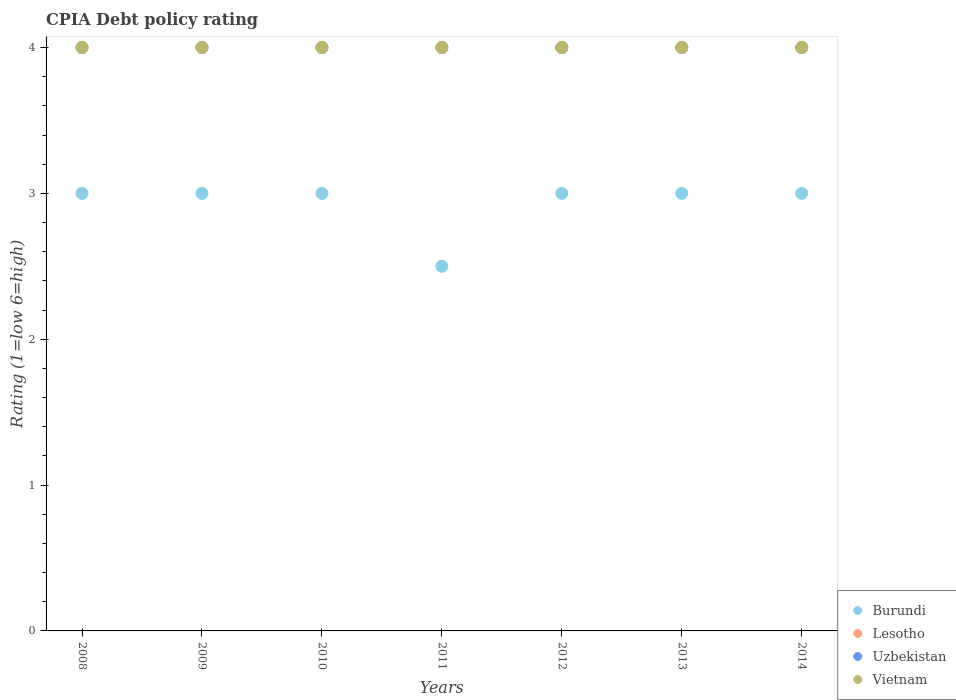What is the CPIA rating in Lesotho in 2011?
Ensure brevity in your answer.  4. Across all years, what is the maximum CPIA rating in Lesotho?
Ensure brevity in your answer.  4. Across all years, what is the minimum CPIA rating in Vietnam?
Ensure brevity in your answer.  4. In the year 2011, what is the difference between the CPIA rating in Lesotho and CPIA rating in Vietnam?
Ensure brevity in your answer.  0. What is the ratio of the CPIA rating in Burundi in 2009 to that in 2012?
Your answer should be very brief. 1. Is the difference between the CPIA rating in Lesotho in 2009 and 2012 greater than the difference between the CPIA rating in Vietnam in 2009 and 2012?
Ensure brevity in your answer.  No. What is the difference between the highest and the second highest CPIA rating in Uzbekistan?
Your answer should be compact. 0. In how many years, is the CPIA rating in Vietnam greater than the average CPIA rating in Vietnam taken over all years?
Ensure brevity in your answer.  0. Is the sum of the CPIA rating in Uzbekistan in 2009 and 2014 greater than the maximum CPIA rating in Vietnam across all years?
Offer a terse response. Yes. Does the CPIA rating in Vietnam monotonically increase over the years?
Give a very brief answer. No. Is the CPIA rating in Burundi strictly greater than the CPIA rating in Uzbekistan over the years?
Make the answer very short. No. Is the CPIA rating in Burundi strictly less than the CPIA rating in Vietnam over the years?
Offer a terse response. Yes. How many dotlines are there?
Keep it short and to the point. 4. Are the values on the major ticks of Y-axis written in scientific E-notation?
Offer a very short reply. No. Does the graph contain any zero values?
Your answer should be very brief. No. Does the graph contain grids?
Give a very brief answer. No. Where does the legend appear in the graph?
Your answer should be compact. Bottom right. How are the legend labels stacked?
Your answer should be very brief. Vertical. What is the title of the graph?
Your answer should be compact. CPIA Debt policy rating. Does "Bahrain" appear as one of the legend labels in the graph?
Keep it short and to the point. No. What is the Rating (1=low 6=high) of Uzbekistan in 2008?
Provide a short and direct response. 4. What is the Rating (1=low 6=high) in Uzbekistan in 2009?
Your response must be concise. 4. What is the Rating (1=low 6=high) of Vietnam in 2009?
Make the answer very short. 4. What is the Rating (1=low 6=high) in Uzbekistan in 2010?
Provide a short and direct response. 4. What is the Rating (1=low 6=high) in Burundi in 2011?
Your response must be concise. 2.5. What is the Rating (1=low 6=high) of Uzbekistan in 2011?
Offer a terse response. 4. What is the Rating (1=low 6=high) of Burundi in 2012?
Make the answer very short. 3. What is the Rating (1=low 6=high) of Lesotho in 2012?
Your answer should be very brief. 4. What is the Rating (1=low 6=high) in Uzbekistan in 2012?
Your response must be concise. 4. What is the Rating (1=low 6=high) in Burundi in 2013?
Give a very brief answer. 3. What is the Rating (1=low 6=high) of Vietnam in 2013?
Offer a terse response. 4. What is the Rating (1=low 6=high) in Burundi in 2014?
Your response must be concise. 3. What is the Rating (1=low 6=high) of Uzbekistan in 2014?
Provide a succinct answer. 4. Across all years, what is the maximum Rating (1=low 6=high) in Uzbekistan?
Offer a terse response. 4. Across all years, what is the minimum Rating (1=low 6=high) of Lesotho?
Provide a succinct answer. 4. What is the difference between the Rating (1=low 6=high) in Burundi in 2008 and that in 2009?
Keep it short and to the point. 0. What is the difference between the Rating (1=low 6=high) of Uzbekistan in 2008 and that in 2009?
Your answer should be very brief. 0. What is the difference between the Rating (1=low 6=high) in Vietnam in 2008 and that in 2009?
Provide a succinct answer. 0. What is the difference between the Rating (1=low 6=high) in Burundi in 2008 and that in 2010?
Provide a short and direct response. 0. What is the difference between the Rating (1=low 6=high) of Lesotho in 2008 and that in 2010?
Your response must be concise. 0. What is the difference between the Rating (1=low 6=high) of Vietnam in 2008 and that in 2010?
Your answer should be compact. 0. What is the difference between the Rating (1=low 6=high) of Burundi in 2008 and that in 2011?
Make the answer very short. 0.5. What is the difference between the Rating (1=low 6=high) of Lesotho in 2008 and that in 2011?
Provide a succinct answer. 0. What is the difference between the Rating (1=low 6=high) in Burundi in 2008 and that in 2012?
Offer a terse response. 0. What is the difference between the Rating (1=low 6=high) of Uzbekistan in 2008 and that in 2014?
Provide a succinct answer. 0. What is the difference between the Rating (1=low 6=high) of Vietnam in 2008 and that in 2014?
Provide a succinct answer. 0. What is the difference between the Rating (1=low 6=high) in Burundi in 2009 and that in 2010?
Your response must be concise. 0. What is the difference between the Rating (1=low 6=high) in Uzbekistan in 2009 and that in 2010?
Keep it short and to the point. 0. What is the difference between the Rating (1=low 6=high) in Vietnam in 2009 and that in 2010?
Your answer should be compact. 0. What is the difference between the Rating (1=low 6=high) of Uzbekistan in 2009 and that in 2011?
Make the answer very short. 0. What is the difference between the Rating (1=low 6=high) of Vietnam in 2009 and that in 2011?
Make the answer very short. 0. What is the difference between the Rating (1=low 6=high) of Uzbekistan in 2009 and that in 2012?
Offer a terse response. 0. What is the difference between the Rating (1=low 6=high) of Vietnam in 2009 and that in 2012?
Your response must be concise. 0. What is the difference between the Rating (1=low 6=high) of Burundi in 2009 and that in 2013?
Provide a succinct answer. 0. What is the difference between the Rating (1=low 6=high) of Uzbekistan in 2009 and that in 2013?
Provide a succinct answer. 0. What is the difference between the Rating (1=low 6=high) in Burundi in 2009 and that in 2014?
Provide a succinct answer. 0. What is the difference between the Rating (1=low 6=high) in Lesotho in 2009 and that in 2014?
Ensure brevity in your answer.  0. What is the difference between the Rating (1=low 6=high) of Uzbekistan in 2009 and that in 2014?
Your answer should be very brief. 0. What is the difference between the Rating (1=low 6=high) of Vietnam in 2009 and that in 2014?
Keep it short and to the point. 0. What is the difference between the Rating (1=low 6=high) in Burundi in 2010 and that in 2012?
Give a very brief answer. 0. What is the difference between the Rating (1=low 6=high) of Lesotho in 2010 and that in 2012?
Make the answer very short. 0. What is the difference between the Rating (1=low 6=high) in Uzbekistan in 2010 and that in 2012?
Provide a succinct answer. 0. What is the difference between the Rating (1=low 6=high) in Vietnam in 2010 and that in 2012?
Offer a very short reply. 0. What is the difference between the Rating (1=low 6=high) in Lesotho in 2010 and that in 2014?
Your answer should be compact. 0. What is the difference between the Rating (1=low 6=high) in Burundi in 2011 and that in 2012?
Ensure brevity in your answer.  -0.5. What is the difference between the Rating (1=low 6=high) of Lesotho in 2011 and that in 2012?
Give a very brief answer. 0. What is the difference between the Rating (1=low 6=high) of Uzbekistan in 2011 and that in 2012?
Provide a succinct answer. 0. What is the difference between the Rating (1=low 6=high) of Vietnam in 2011 and that in 2012?
Provide a short and direct response. 0. What is the difference between the Rating (1=low 6=high) of Lesotho in 2011 and that in 2013?
Provide a short and direct response. 0. What is the difference between the Rating (1=low 6=high) of Vietnam in 2011 and that in 2013?
Make the answer very short. 0. What is the difference between the Rating (1=low 6=high) in Uzbekistan in 2011 and that in 2014?
Offer a very short reply. 0. What is the difference between the Rating (1=low 6=high) in Burundi in 2012 and that in 2013?
Offer a very short reply. 0. What is the difference between the Rating (1=low 6=high) of Lesotho in 2012 and that in 2013?
Keep it short and to the point. 0. What is the difference between the Rating (1=low 6=high) of Vietnam in 2012 and that in 2013?
Offer a terse response. 0. What is the difference between the Rating (1=low 6=high) in Burundi in 2012 and that in 2014?
Make the answer very short. 0. What is the difference between the Rating (1=low 6=high) in Lesotho in 2012 and that in 2014?
Your response must be concise. 0. What is the difference between the Rating (1=low 6=high) of Vietnam in 2012 and that in 2014?
Offer a very short reply. 0. What is the difference between the Rating (1=low 6=high) in Uzbekistan in 2013 and that in 2014?
Give a very brief answer. 0. What is the difference between the Rating (1=low 6=high) in Burundi in 2008 and the Rating (1=low 6=high) in Uzbekistan in 2009?
Your response must be concise. -1. What is the difference between the Rating (1=low 6=high) in Uzbekistan in 2008 and the Rating (1=low 6=high) in Vietnam in 2009?
Make the answer very short. 0. What is the difference between the Rating (1=low 6=high) of Burundi in 2008 and the Rating (1=low 6=high) of Uzbekistan in 2010?
Offer a very short reply. -1. What is the difference between the Rating (1=low 6=high) of Lesotho in 2008 and the Rating (1=low 6=high) of Vietnam in 2010?
Give a very brief answer. 0. What is the difference between the Rating (1=low 6=high) in Burundi in 2008 and the Rating (1=low 6=high) in Lesotho in 2011?
Ensure brevity in your answer.  -1. What is the difference between the Rating (1=low 6=high) in Lesotho in 2008 and the Rating (1=low 6=high) in Uzbekistan in 2011?
Your answer should be compact. 0. What is the difference between the Rating (1=low 6=high) of Uzbekistan in 2008 and the Rating (1=low 6=high) of Vietnam in 2011?
Offer a terse response. 0. What is the difference between the Rating (1=low 6=high) in Burundi in 2008 and the Rating (1=low 6=high) in Uzbekistan in 2012?
Make the answer very short. -1. What is the difference between the Rating (1=low 6=high) in Burundi in 2008 and the Rating (1=low 6=high) in Vietnam in 2012?
Your response must be concise. -1. What is the difference between the Rating (1=low 6=high) of Lesotho in 2008 and the Rating (1=low 6=high) of Uzbekistan in 2012?
Provide a short and direct response. 0. What is the difference between the Rating (1=low 6=high) of Uzbekistan in 2008 and the Rating (1=low 6=high) of Vietnam in 2012?
Give a very brief answer. 0. What is the difference between the Rating (1=low 6=high) in Burundi in 2008 and the Rating (1=low 6=high) in Uzbekistan in 2013?
Make the answer very short. -1. What is the difference between the Rating (1=low 6=high) in Lesotho in 2008 and the Rating (1=low 6=high) in Uzbekistan in 2013?
Your response must be concise. 0. What is the difference between the Rating (1=low 6=high) of Lesotho in 2008 and the Rating (1=low 6=high) of Vietnam in 2013?
Offer a very short reply. 0. What is the difference between the Rating (1=low 6=high) of Uzbekistan in 2008 and the Rating (1=low 6=high) of Vietnam in 2013?
Provide a succinct answer. 0. What is the difference between the Rating (1=low 6=high) of Burundi in 2008 and the Rating (1=low 6=high) of Uzbekistan in 2014?
Provide a short and direct response. -1. What is the difference between the Rating (1=low 6=high) of Uzbekistan in 2008 and the Rating (1=low 6=high) of Vietnam in 2014?
Give a very brief answer. 0. What is the difference between the Rating (1=low 6=high) in Burundi in 2009 and the Rating (1=low 6=high) in Lesotho in 2010?
Your answer should be very brief. -1. What is the difference between the Rating (1=low 6=high) of Burundi in 2009 and the Rating (1=low 6=high) of Uzbekistan in 2010?
Provide a succinct answer. -1. What is the difference between the Rating (1=low 6=high) of Lesotho in 2009 and the Rating (1=low 6=high) of Uzbekistan in 2010?
Provide a short and direct response. 0. What is the difference between the Rating (1=low 6=high) in Lesotho in 2009 and the Rating (1=low 6=high) in Vietnam in 2010?
Your answer should be compact. 0. What is the difference between the Rating (1=low 6=high) of Uzbekistan in 2009 and the Rating (1=low 6=high) of Vietnam in 2010?
Keep it short and to the point. 0. What is the difference between the Rating (1=low 6=high) in Burundi in 2009 and the Rating (1=low 6=high) in Lesotho in 2011?
Make the answer very short. -1. What is the difference between the Rating (1=low 6=high) in Burundi in 2009 and the Rating (1=low 6=high) in Uzbekistan in 2011?
Ensure brevity in your answer.  -1. What is the difference between the Rating (1=low 6=high) of Burundi in 2009 and the Rating (1=low 6=high) of Vietnam in 2011?
Keep it short and to the point. -1. What is the difference between the Rating (1=low 6=high) of Uzbekistan in 2009 and the Rating (1=low 6=high) of Vietnam in 2011?
Provide a short and direct response. 0. What is the difference between the Rating (1=low 6=high) in Burundi in 2009 and the Rating (1=low 6=high) in Uzbekistan in 2012?
Keep it short and to the point. -1. What is the difference between the Rating (1=low 6=high) in Uzbekistan in 2009 and the Rating (1=low 6=high) in Vietnam in 2012?
Your answer should be very brief. 0. What is the difference between the Rating (1=low 6=high) of Burundi in 2009 and the Rating (1=low 6=high) of Vietnam in 2013?
Your answer should be compact. -1. What is the difference between the Rating (1=low 6=high) of Lesotho in 2009 and the Rating (1=low 6=high) of Vietnam in 2013?
Your answer should be very brief. 0. What is the difference between the Rating (1=low 6=high) in Uzbekistan in 2009 and the Rating (1=low 6=high) in Vietnam in 2013?
Ensure brevity in your answer.  0. What is the difference between the Rating (1=low 6=high) of Burundi in 2009 and the Rating (1=low 6=high) of Uzbekistan in 2014?
Offer a very short reply. -1. What is the difference between the Rating (1=low 6=high) of Burundi in 2009 and the Rating (1=low 6=high) of Vietnam in 2014?
Your response must be concise. -1. What is the difference between the Rating (1=low 6=high) of Lesotho in 2009 and the Rating (1=low 6=high) of Vietnam in 2014?
Your answer should be compact. 0. What is the difference between the Rating (1=low 6=high) in Burundi in 2010 and the Rating (1=low 6=high) in Vietnam in 2011?
Keep it short and to the point. -1. What is the difference between the Rating (1=low 6=high) in Lesotho in 2010 and the Rating (1=low 6=high) in Uzbekistan in 2011?
Ensure brevity in your answer.  0. What is the difference between the Rating (1=low 6=high) in Lesotho in 2010 and the Rating (1=low 6=high) in Vietnam in 2011?
Ensure brevity in your answer.  0. What is the difference between the Rating (1=low 6=high) of Burundi in 2010 and the Rating (1=low 6=high) of Lesotho in 2012?
Your answer should be very brief. -1. What is the difference between the Rating (1=low 6=high) in Lesotho in 2010 and the Rating (1=low 6=high) in Uzbekistan in 2012?
Your answer should be compact. 0. What is the difference between the Rating (1=low 6=high) in Lesotho in 2010 and the Rating (1=low 6=high) in Vietnam in 2012?
Offer a very short reply. 0. What is the difference between the Rating (1=low 6=high) in Burundi in 2010 and the Rating (1=low 6=high) in Lesotho in 2013?
Your response must be concise. -1. What is the difference between the Rating (1=low 6=high) in Burundi in 2010 and the Rating (1=low 6=high) in Uzbekistan in 2013?
Keep it short and to the point. -1. What is the difference between the Rating (1=low 6=high) in Lesotho in 2010 and the Rating (1=low 6=high) in Vietnam in 2013?
Offer a terse response. 0. What is the difference between the Rating (1=low 6=high) in Burundi in 2010 and the Rating (1=low 6=high) in Vietnam in 2014?
Provide a succinct answer. -1. What is the difference between the Rating (1=low 6=high) in Lesotho in 2010 and the Rating (1=low 6=high) in Uzbekistan in 2014?
Ensure brevity in your answer.  0. What is the difference between the Rating (1=low 6=high) in Lesotho in 2010 and the Rating (1=low 6=high) in Vietnam in 2014?
Offer a very short reply. 0. What is the difference between the Rating (1=low 6=high) in Uzbekistan in 2010 and the Rating (1=low 6=high) in Vietnam in 2014?
Your answer should be very brief. 0. What is the difference between the Rating (1=low 6=high) of Burundi in 2011 and the Rating (1=low 6=high) of Lesotho in 2012?
Keep it short and to the point. -1.5. What is the difference between the Rating (1=low 6=high) of Burundi in 2011 and the Rating (1=low 6=high) of Uzbekistan in 2012?
Keep it short and to the point. -1.5. What is the difference between the Rating (1=low 6=high) of Burundi in 2011 and the Rating (1=low 6=high) of Vietnam in 2012?
Ensure brevity in your answer.  -1.5. What is the difference between the Rating (1=low 6=high) in Uzbekistan in 2011 and the Rating (1=low 6=high) in Vietnam in 2012?
Offer a very short reply. 0. What is the difference between the Rating (1=low 6=high) in Burundi in 2011 and the Rating (1=low 6=high) in Lesotho in 2013?
Provide a succinct answer. -1.5. What is the difference between the Rating (1=low 6=high) of Lesotho in 2011 and the Rating (1=low 6=high) of Vietnam in 2013?
Give a very brief answer. 0. What is the difference between the Rating (1=low 6=high) in Burundi in 2011 and the Rating (1=low 6=high) in Lesotho in 2014?
Your response must be concise. -1.5. What is the difference between the Rating (1=low 6=high) of Lesotho in 2011 and the Rating (1=low 6=high) of Uzbekistan in 2014?
Provide a succinct answer. 0. What is the difference between the Rating (1=low 6=high) in Lesotho in 2011 and the Rating (1=low 6=high) in Vietnam in 2014?
Provide a short and direct response. 0. What is the difference between the Rating (1=low 6=high) in Uzbekistan in 2011 and the Rating (1=low 6=high) in Vietnam in 2014?
Give a very brief answer. 0. What is the difference between the Rating (1=low 6=high) of Burundi in 2012 and the Rating (1=low 6=high) of Lesotho in 2013?
Your answer should be very brief. -1. What is the difference between the Rating (1=low 6=high) in Burundi in 2012 and the Rating (1=low 6=high) in Uzbekistan in 2013?
Give a very brief answer. -1. What is the difference between the Rating (1=low 6=high) in Burundi in 2012 and the Rating (1=low 6=high) in Lesotho in 2014?
Provide a succinct answer. -1. What is the difference between the Rating (1=low 6=high) in Burundi in 2012 and the Rating (1=low 6=high) in Uzbekistan in 2014?
Offer a very short reply. -1. What is the difference between the Rating (1=low 6=high) in Burundi in 2012 and the Rating (1=low 6=high) in Vietnam in 2014?
Provide a short and direct response. -1. What is the difference between the Rating (1=low 6=high) of Lesotho in 2012 and the Rating (1=low 6=high) of Uzbekistan in 2014?
Offer a terse response. 0. What is the difference between the Rating (1=low 6=high) of Burundi in 2013 and the Rating (1=low 6=high) of Vietnam in 2014?
Your answer should be compact. -1. What is the average Rating (1=low 6=high) in Burundi per year?
Give a very brief answer. 2.93. What is the average Rating (1=low 6=high) of Lesotho per year?
Your answer should be very brief. 4. What is the average Rating (1=low 6=high) in Uzbekistan per year?
Provide a short and direct response. 4. In the year 2008, what is the difference between the Rating (1=low 6=high) of Burundi and Rating (1=low 6=high) of Uzbekistan?
Your answer should be very brief. -1. In the year 2008, what is the difference between the Rating (1=low 6=high) of Burundi and Rating (1=low 6=high) of Vietnam?
Your response must be concise. -1. In the year 2008, what is the difference between the Rating (1=low 6=high) of Uzbekistan and Rating (1=low 6=high) of Vietnam?
Provide a short and direct response. 0. In the year 2009, what is the difference between the Rating (1=low 6=high) in Burundi and Rating (1=low 6=high) in Vietnam?
Your answer should be compact. -1. In the year 2009, what is the difference between the Rating (1=low 6=high) of Lesotho and Rating (1=low 6=high) of Vietnam?
Ensure brevity in your answer.  0. In the year 2009, what is the difference between the Rating (1=low 6=high) in Uzbekistan and Rating (1=low 6=high) in Vietnam?
Offer a very short reply. 0. In the year 2010, what is the difference between the Rating (1=low 6=high) of Burundi and Rating (1=low 6=high) of Lesotho?
Ensure brevity in your answer.  -1. In the year 2010, what is the difference between the Rating (1=low 6=high) of Burundi and Rating (1=low 6=high) of Uzbekistan?
Make the answer very short. -1. In the year 2010, what is the difference between the Rating (1=low 6=high) in Burundi and Rating (1=low 6=high) in Vietnam?
Provide a short and direct response. -1. In the year 2010, what is the difference between the Rating (1=low 6=high) of Lesotho and Rating (1=low 6=high) of Vietnam?
Your answer should be very brief. 0. In the year 2010, what is the difference between the Rating (1=low 6=high) of Uzbekistan and Rating (1=low 6=high) of Vietnam?
Ensure brevity in your answer.  0. In the year 2011, what is the difference between the Rating (1=low 6=high) in Burundi and Rating (1=low 6=high) in Uzbekistan?
Offer a very short reply. -1.5. In the year 2011, what is the difference between the Rating (1=low 6=high) of Burundi and Rating (1=low 6=high) of Vietnam?
Provide a succinct answer. -1.5. In the year 2011, what is the difference between the Rating (1=low 6=high) of Lesotho and Rating (1=low 6=high) of Uzbekistan?
Offer a terse response. 0. In the year 2011, what is the difference between the Rating (1=low 6=high) in Uzbekistan and Rating (1=low 6=high) in Vietnam?
Your answer should be compact. 0. In the year 2012, what is the difference between the Rating (1=low 6=high) in Burundi and Rating (1=low 6=high) in Uzbekistan?
Keep it short and to the point. -1. In the year 2012, what is the difference between the Rating (1=low 6=high) in Burundi and Rating (1=low 6=high) in Vietnam?
Give a very brief answer. -1. In the year 2012, what is the difference between the Rating (1=low 6=high) of Lesotho and Rating (1=low 6=high) of Uzbekistan?
Ensure brevity in your answer.  0. In the year 2013, what is the difference between the Rating (1=low 6=high) of Burundi and Rating (1=low 6=high) of Uzbekistan?
Make the answer very short. -1. In the year 2013, what is the difference between the Rating (1=low 6=high) of Lesotho and Rating (1=low 6=high) of Uzbekistan?
Your answer should be very brief. 0. In the year 2013, what is the difference between the Rating (1=low 6=high) of Uzbekistan and Rating (1=low 6=high) of Vietnam?
Give a very brief answer. 0. In the year 2014, what is the difference between the Rating (1=low 6=high) in Burundi and Rating (1=low 6=high) in Lesotho?
Your response must be concise. -1. In the year 2014, what is the difference between the Rating (1=low 6=high) of Burundi and Rating (1=low 6=high) of Uzbekistan?
Provide a short and direct response. -1. In the year 2014, what is the difference between the Rating (1=low 6=high) in Lesotho and Rating (1=low 6=high) in Uzbekistan?
Your answer should be compact. 0. In the year 2014, what is the difference between the Rating (1=low 6=high) of Lesotho and Rating (1=low 6=high) of Vietnam?
Your response must be concise. 0. What is the ratio of the Rating (1=low 6=high) of Burundi in 2008 to that in 2009?
Make the answer very short. 1. What is the ratio of the Rating (1=low 6=high) in Lesotho in 2008 to that in 2009?
Offer a very short reply. 1. What is the ratio of the Rating (1=low 6=high) of Uzbekistan in 2008 to that in 2009?
Ensure brevity in your answer.  1. What is the ratio of the Rating (1=low 6=high) of Vietnam in 2008 to that in 2009?
Provide a short and direct response. 1. What is the ratio of the Rating (1=low 6=high) in Lesotho in 2008 to that in 2010?
Give a very brief answer. 1. What is the ratio of the Rating (1=low 6=high) of Uzbekistan in 2008 to that in 2010?
Keep it short and to the point. 1. What is the ratio of the Rating (1=low 6=high) in Burundi in 2008 to that in 2011?
Provide a short and direct response. 1.2. What is the ratio of the Rating (1=low 6=high) in Lesotho in 2008 to that in 2011?
Ensure brevity in your answer.  1. What is the ratio of the Rating (1=low 6=high) of Uzbekistan in 2008 to that in 2011?
Provide a succinct answer. 1. What is the ratio of the Rating (1=low 6=high) in Vietnam in 2008 to that in 2011?
Your answer should be very brief. 1. What is the ratio of the Rating (1=low 6=high) in Burundi in 2008 to that in 2012?
Your response must be concise. 1. What is the ratio of the Rating (1=low 6=high) of Vietnam in 2008 to that in 2012?
Your answer should be very brief. 1. What is the ratio of the Rating (1=low 6=high) of Lesotho in 2008 to that in 2013?
Provide a short and direct response. 1. What is the ratio of the Rating (1=low 6=high) in Lesotho in 2008 to that in 2014?
Offer a terse response. 1. What is the ratio of the Rating (1=low 6=high) in Lesotho in 2009 to that in 2010?
Ensure brevity in your answer.  1. What is the ratio of the Rating (1=low 6=high) of Vietnam in 2009 to that in 2010?
Ensure brevity in your answer.  1. What is the ratio of the Rating (1=low 6=high) in Lesotho in 2009 to that in 2011?
Keep it short and to the point. 1. What is the ratio of the Rating (1=low 6=high) in Uzbekistan in 2009 to that in 2011?
Provide a short and direct response. 1. What is the ratio of the Rating (1=low 6=high) of Vietnam in 2009 to that in 2011?
Provide a short and direct response. 1. What is the ratio of the Rating (1=low 6=high) in Lesotho in 2009 to that in 2012?
Your answer should be very brief. 1. What is the ratio of the Rating (1=low 6=high) in Vietnam in 2009 to that in 2012?
Make the answer very short. 1. What is the ratio of the Rating (1=low 6=high) of Lesotho in 2009 to that in 2013?
Your answer should be compact. 1. What is the ratio of the Rating (1=low 6=high) in Vietnam in 2009 to that in 2013?
Give a very brief answer. 1. What is the ratio of the Rating (1=low 6=high) of Lesotho in 2009 to that in 2014?
Your answer should be very brief. 1. What is the ratio of the Rating (1=low 6=high) of Lesotho in 2010 to that in 2011?
Make the answer very short. 1. What is the ratio of the Rating (1=low 6=high) of Burundi in 2010 to that in 2012?
Provide a succinct answer. 1. What is the ratio of the Rating (1=low 6=high) of Lesotho in 2010 to that in 2012?
Give a very brief answer. 1. What is the ratio of the Rating (1=low 6=high) in Uzbekistan in 2010 to that in 2012?
Provide a short and direct response. 1. What is the ratio of the Rating (1=low 6=high) in Burundi in 2010 to that in 2013?
Keep it short and to the point. 1. What is the ratio of the Rating (1=low 6=high) of Lesotho in 2010 to that in 2013?
Provide a short and direct response. 1. What is the ratio of the Rating (1=low 6=high) in Vietnam in 2010 to that in 2013?
Offer a terse response. 1. What is the ratio of the Rating (1=low 6=high) in Uzbekistan in 2010 to that in 2014?
Offer a very short reply. 1. What is the ratio of the Rating (1=low 6=high) of Vietnam in 2010 to that in 2014?
Make the answer very short. 1. What is the ratio of the Rating (1=low 6=high) of Burundi in 2011 to that in 2012?
Give a very brief answer. 0.83. What is the ratio of the Rating (1=low 6=high) of Lesotho in 2011 to that in 2012?
Provide a succinct answer. 1. What is the ratio of the Rating (1=low 6=high) in Lesotho in 2011 to that in 2013?
Keep it short and to the point. 1. What is the ratio of the Rating (1=low 6=high) of Uzbekistan in 2011 to that in 2013?
Provide a short and direct response. 1. What is the ratio of the Rating (1=low 6=high) of Burundi in 2011 to that in 2014?
Provide a succinct answer. 0.83. What is the ratio of the Rating (1=low 6=high) in Burundi in 2012 to that in 2013?
Offer a terse response. 1. What is the ratio of the Rating (1=low 6=high) in Uzbekistan in 2012 to that in 2014?
Make the answer very short. 1. What is the ratio of the Rating (1=low 6=high) in Burundi in 2013 to that in 2014?
Give a very brief answer. 1. What is the ratio of the Rating (1=low 6=high) in Lesotho in 2013 to that in 2014?
Offer a terse response. 1. What is the ratio of the Rating (1=low 6=high) of Uzbekistan in 2013 to that in 2014?
Make the answer very short. 1. What is the ratio of the Rating (1=low 6=high) in Vietnam in 2013 to that in 2014?
Provide a succinct answer. 1. What is the difference between the highest and the second highest Rating (1=low 6=high) in Burundi?
Ensure brevity in your answer.  0. What is the difference between the highest and the second highest Rating (1=low 6=high) of Uzbekistan?
Provide a short and direct response. 0. What is the difference between the highest and the second highest Rating (1=low 6=high) in Vietnam?
Your answer should be compact. 0. What is the difference between the highest and the lowest Rating (1=low 6=high) in Burundi?
Ensure brevity in your answer.  0.5. What is the difference between the highest and the lowest Rating (1=low 6=high) in Lesotho?
Your answer should be compact. 0. 